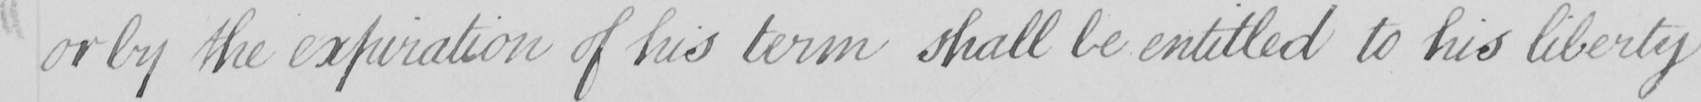Transcribe the text shown in this historical manuscript line. or by the expiration of his term shall be entitled to his liberty 